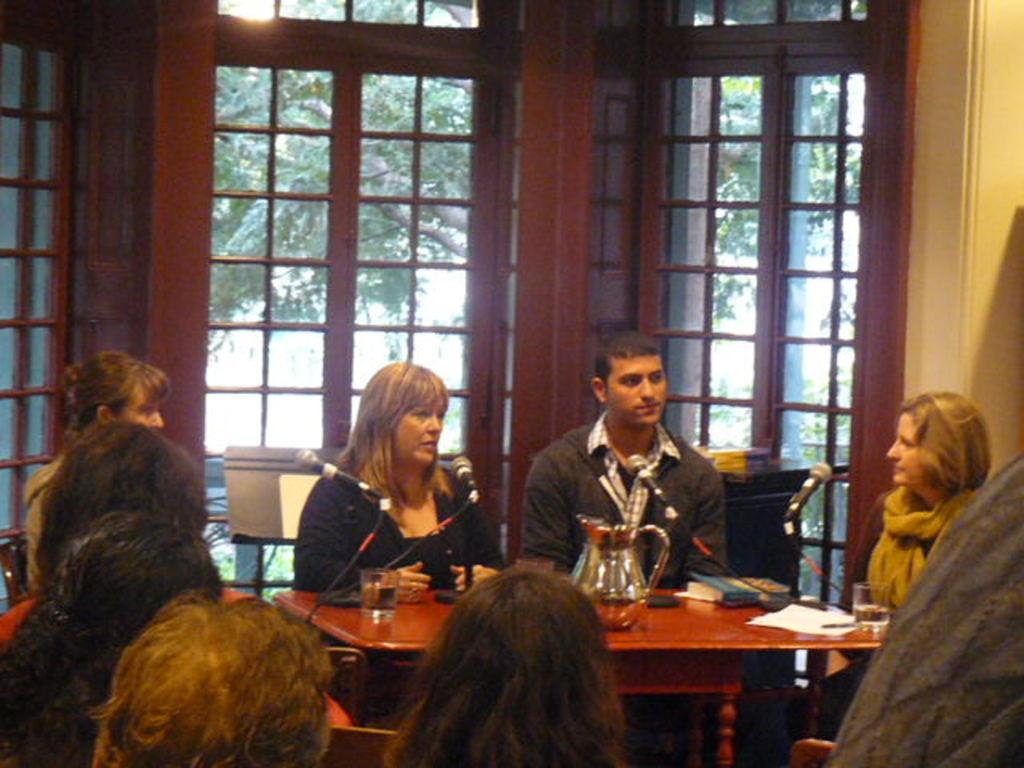In one or two sentences, can you explain what this image depicts? In This picture there are people in the center of the image, they are sitting around a table, there are glasses, books, and mics and there are windows in the center of the image. 